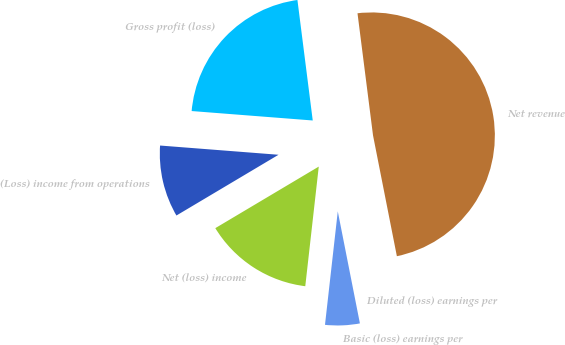<chart> <loc_0><loc_0><loc_500><loc_500><pie_chart><fcel>Net revenue<fcel>Gross profit (loss)<fcel>(Loss) income from operations<fcel>Net (loss) income<fcel>Basic (loss) earnings per<fcel>Diluted (loss) earnings per<nl><fcel>48.91%<fcel>21.75%<fcel>9.78%<fcel>14.67%<fcel>4.89%<fcel>0.0%<nl></chart> 